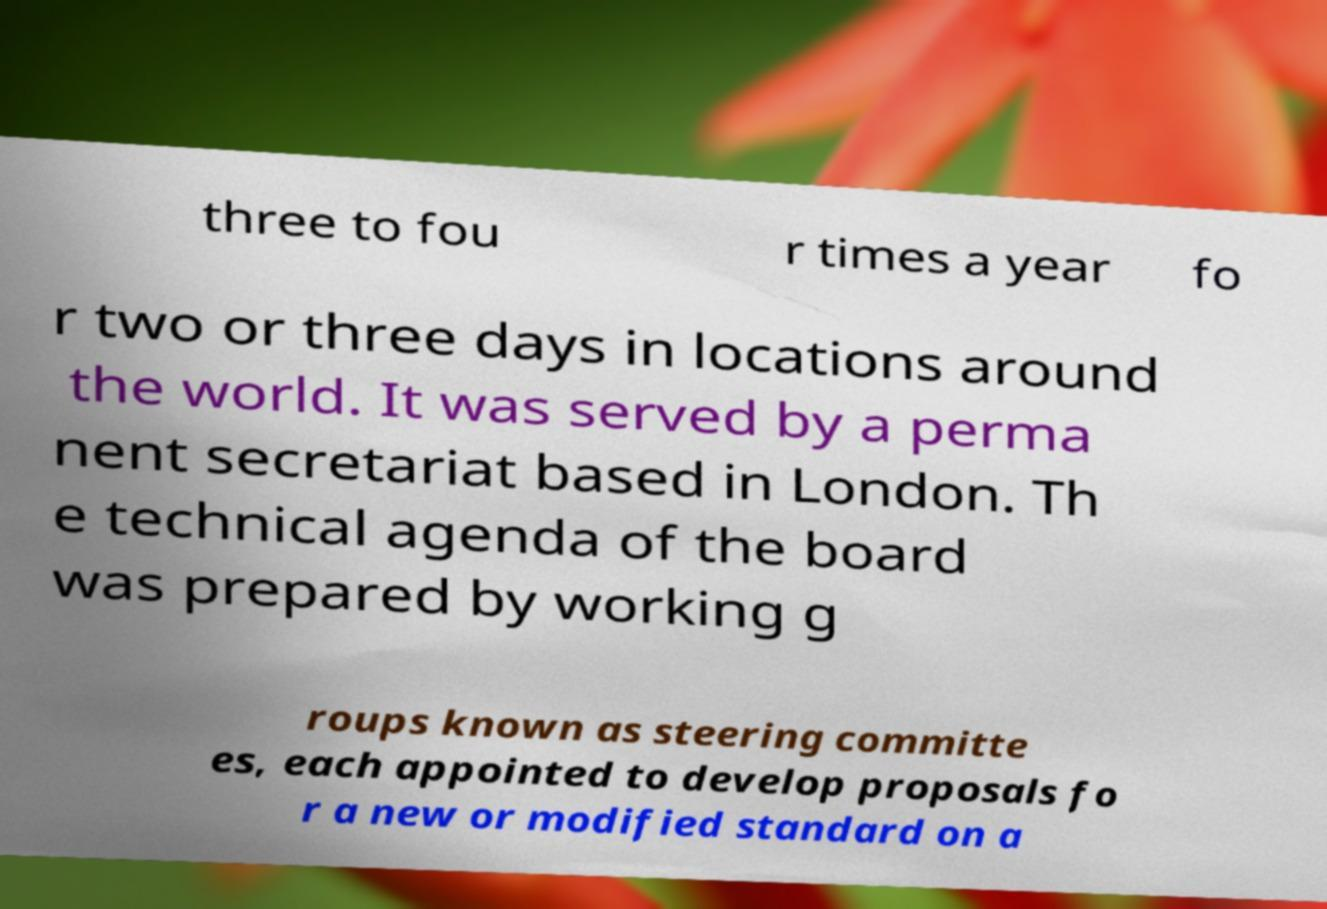Could you assist in decoding the text presented in this image and type it out clearly? three to fou r times a year fo r two or three days in locations around the world. It was served by a perma nent secretariat based in London. Th e technical agenda of the board was prepared by working g roups known as steering committe es, each appointed to develop proposals fo r a new or modified standard on a 